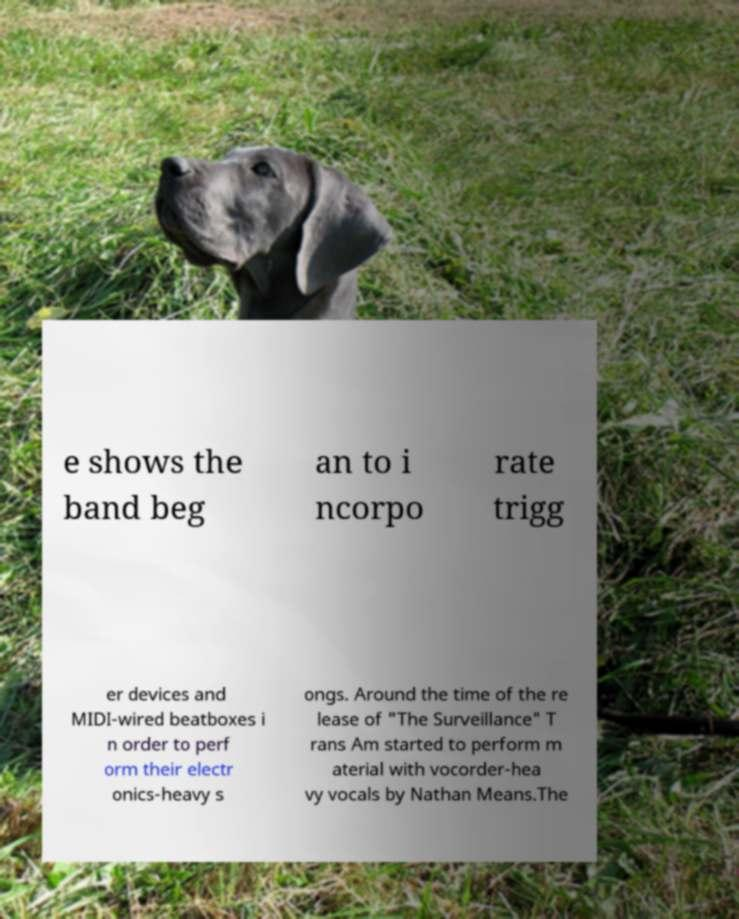What messages or text are displayed in this image? I need them in a readable, typed format. e shows the band beg an to i ncorpo rate trigg er devices and MIDI-wired beatboxes i n order to perf orm their electr onics-heavy s ongs. Around the time of the re lease of "The Surveillance" T rans Am started to perform m aterial with vocorder-hea vy vocals by Nathan Means.The 